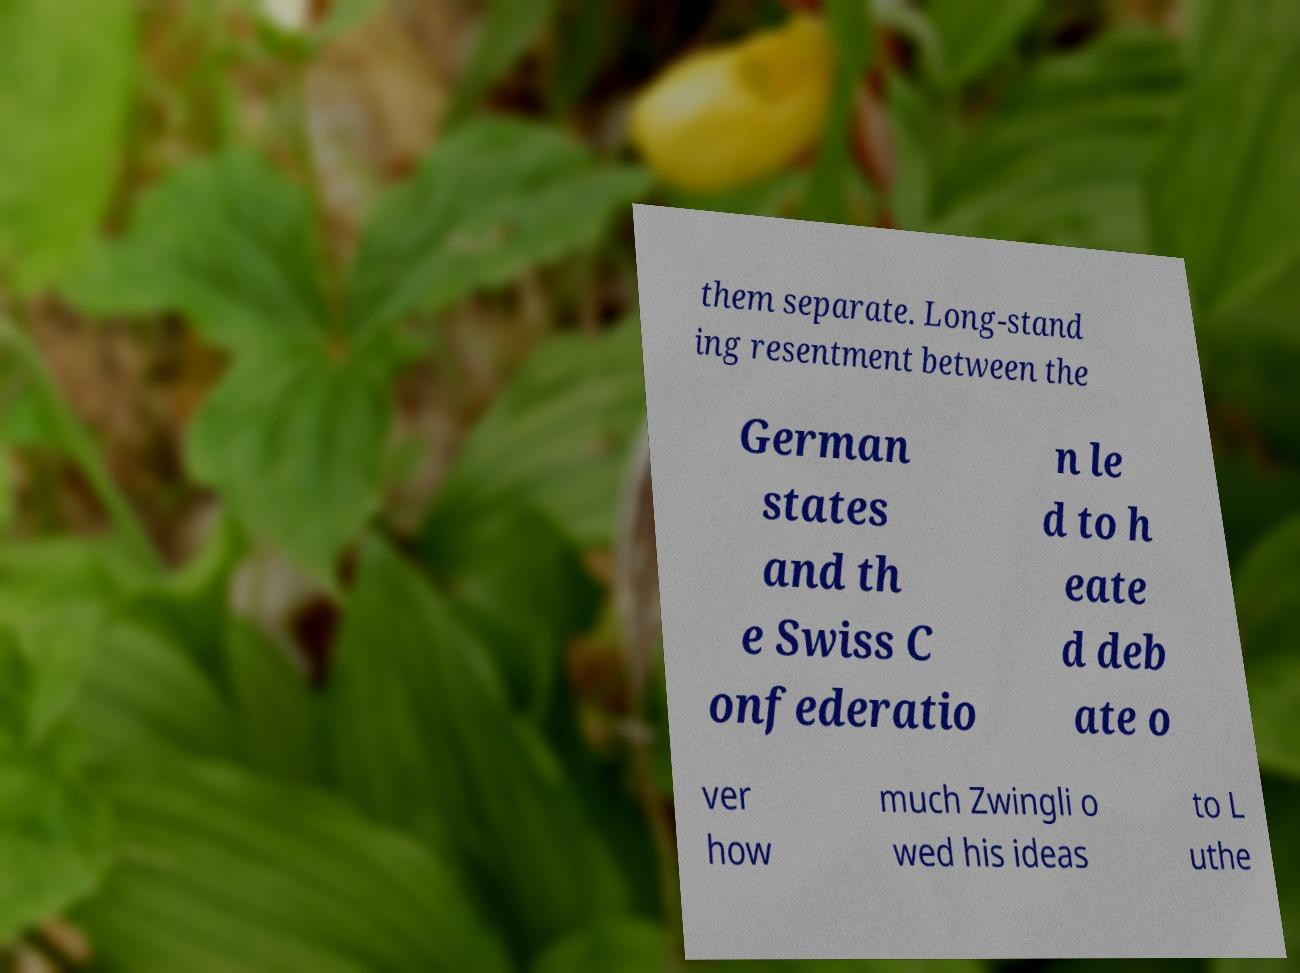Can you accurately transcribe the text from the provided image for me? them separate. Long-stand ing resentment between the German states and th e Swiss C onfederatio n le d to h eate d deb ate o ver how much Zwingli o wed his ideas to L uthe 